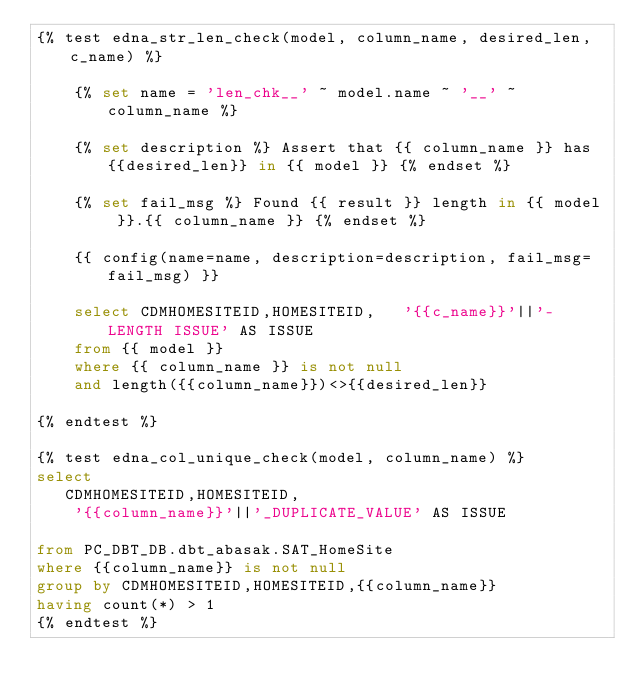Convert code to text. <code><loc_0><loc_0><loc_500><loc_500><_SQL_>{% test edna_str_len_check(model, column_name, desired_len,c_name) %}

    {% set name = 'len_chk__' ~ model.name ~ '__' ~ column_name %}

    {% set description %} Assert that {{ column_name }} has {{desired_len}} in {{ model }} {% endset %}

    {% set fail_msg %} Found {{ result }} length in {{ model }}.{{ column_name }} {% endset %}
        
    {{ config(name=name, description=description, fail_msg=fail_msg) }}
    
    select CDMHOMESITEID,HOMESITEID,   '{{c_name}}'||'-LENGTH ISSUE' AS ISSUE
    from {{ model }}
    where {{ column_name }} is not null 
    and length({{column_name}})<>{{desired_len}}

{% endtest %}

{% test edna_col_unique_check(model, column_name) %}
select
   CDMHOMESITEID,HOMESITEID,
    '{{column_name}}'||'_DUPLICATE_VALUE' AS ISSUE

from PC_DBT_DB.dbt_abasak.SAT_HomeSite
where {{column_name}} is not null
group by CDMHOMESITEID,HOMESITEID,{{column_name}}
having count(*) > 1
{% endtest %}</code> 